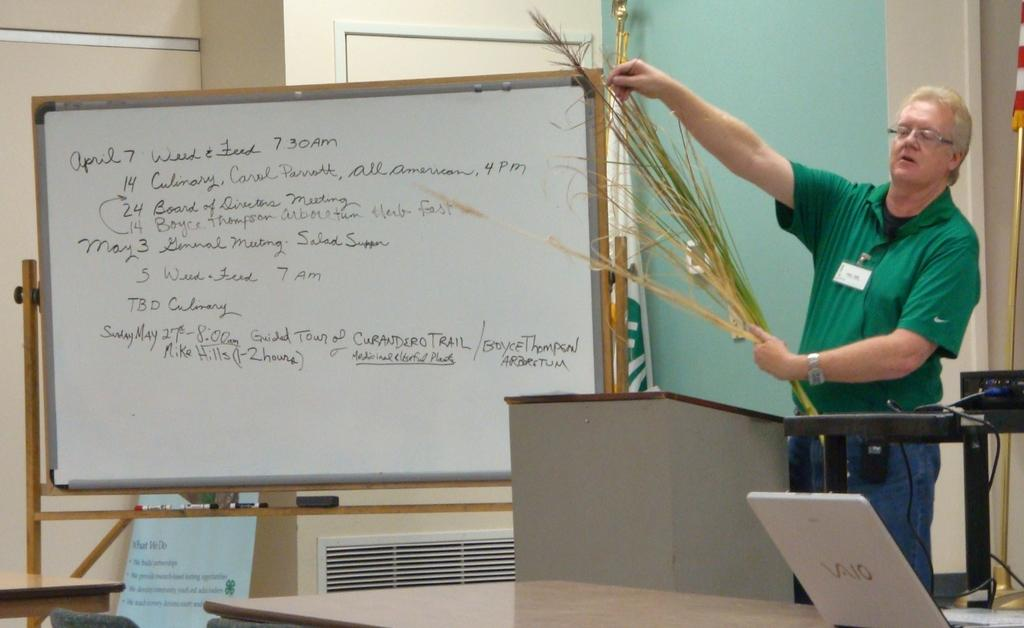<image>
Give a short and clear explanation of the subsequent image. Man in green is giving a presentation next to a board that says April 7. 